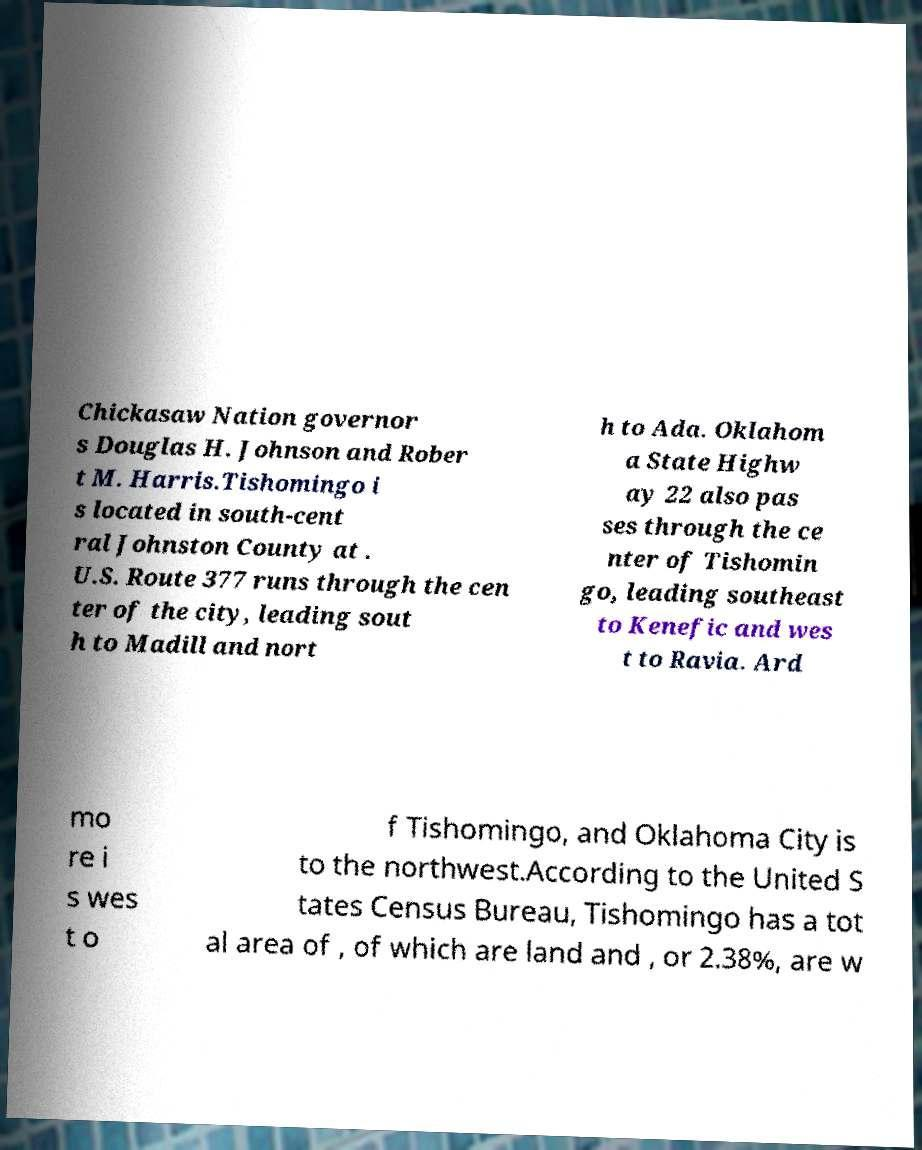Can you accurately transcribe the text from the provided image for me? Chickasaw Nation governor s Douglas H. Johnson and Rober t M. Harris.Tishomingo i s located in south-cent ral Johnston County at . U.S. Route 377 runs through the cen ter of the city, leading sout h to Madill and nort h to Ada. Oklahom a State Highw ay 22 also pas ses through the ce nter of Tishomin go, leading southeast to Kenefic and wes t to Ravia. Ard mo re i s wes t o f Tishomingo, and Oklahoma City is to the northwest.According to the United S tates Census Bureau, Tishomingo has a tot al area of , of which are land and , or 2.38%, are w 